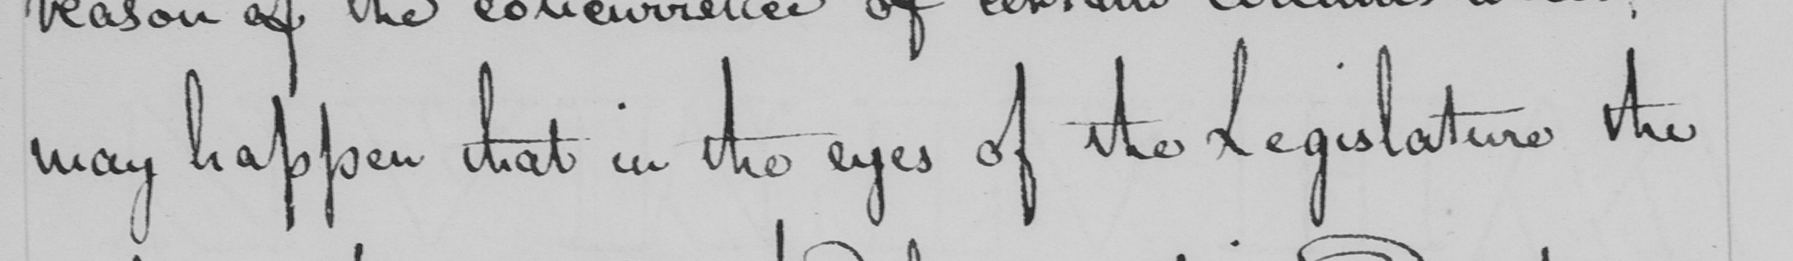What text is written in this handwritten line? may happen that in the eyes of the Legislature the 